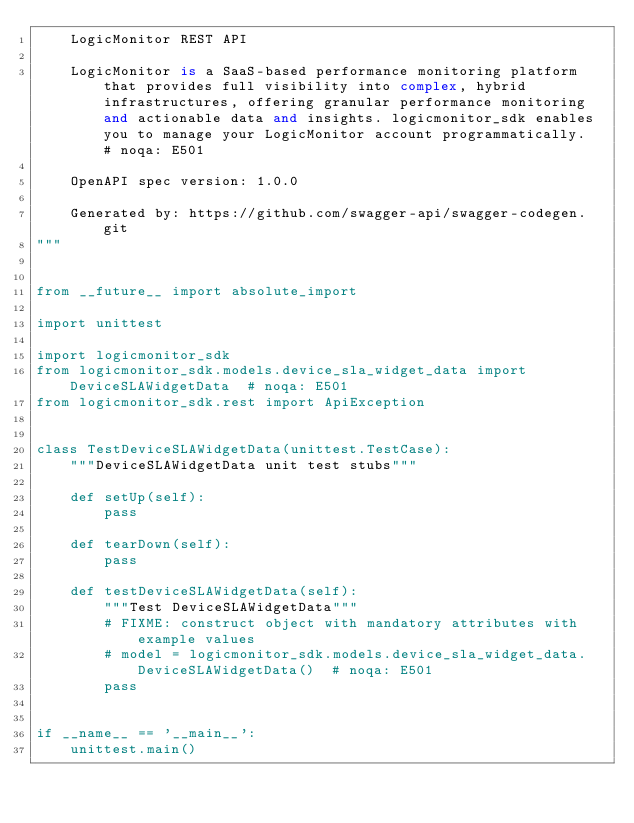<code> <loc_0><loc_0><loc_500><loc_500><_Python_>    LogicMonitor REST API

    LogicMonitor is a SaaS-based performance monitoring platform that provides full visibility into complex, hybrid infrastructures, offering granular performance monitoring and actionable data and insights. logicmonitor_sdk enables you to manage your LogicMonitor account programmatically.  # noqa: E501

    OpenAPI spec version: 1.0.0
    
    Generated by: https://github.com/swagger-api/swagger-codegen.git
"""


from __future__ import absolute_import

import unittest

import logicmonitor_sdk
from logicmonitor_sdk.models.device_sla_widget_data import DeviceSLAWidgetData  # noqa: E501
from logicmonitor_sdk.rest import ApiException


class TestDeviceSLAWidgetData(unittest.TestCase):
    """DeviceSLAWidgetData unit test stubs"""

    def setUp(self):
        pass

    def tearDown(self):
        pass

    def testDeviceSLAWidgetData(self):
        """Test DeviceSLAWidgetData"""
        # FIXME: construct object with mandatory attributes with example values
        # model = logicmonitor_sdk.models.device_sla_widget_data.DeviceSLAWidgetData()  # noqa: E501
        pass


if __name__ == '__main__':
    unittest.main()
</code> 